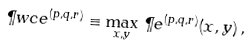<formula> <loc_0><loc_0><loc_500><loc_500>\P w c e ^ { ( p , q , r ) } \equiv \max _ { x , y } \, \P e ^ { ( p , q , r ) } ( x , y ) \, ,</formula> 